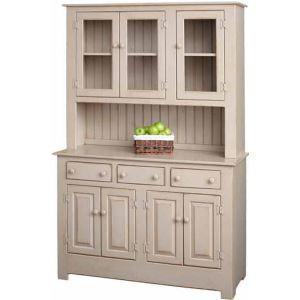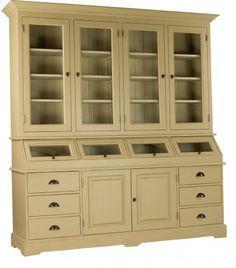The first image is the image on the left, the second image is the image on the right. Considering the images on both sides, is "Both of the cabinets depicted have flat tops and some type of feet." valid? Answer yes or no. Yes. The first image is the image on the left, the second image is the image on the right. Considering the images on both sides, is "Two wooden hutches, both with straight flat upper edges, are different widths." valid? Answer yes or no. Yes. 